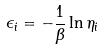<formula> <loc_0><loc_0><loc_500><loc_500>\epsilon _ { i } = - \frac { 1 } { \beta } \ln \eta _ { i }</formula> 